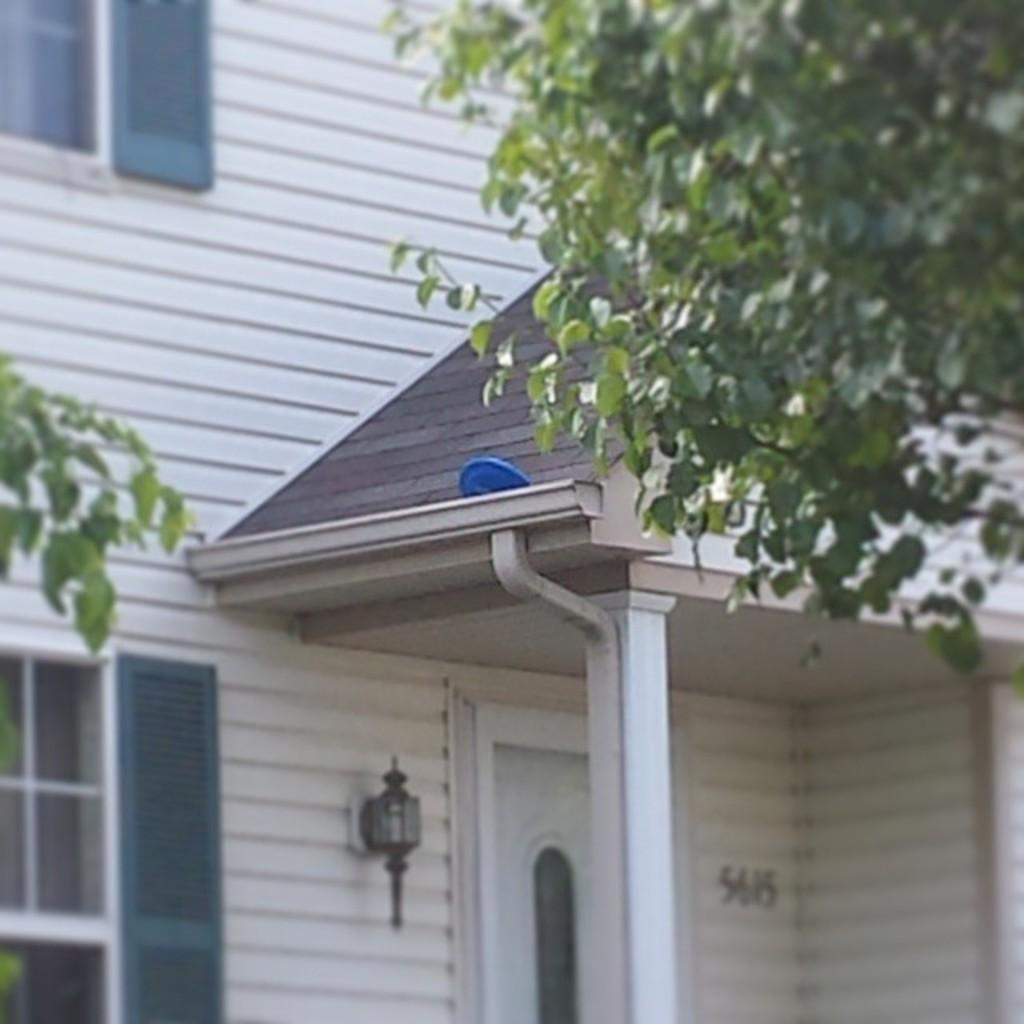What is the main subject of the picture? The main subject of the picture is a house. What can be seen in front of the house? There are trees in front of the house. How many sheep are grazing in the front yard of the house in the image? There are no sheep present in the image; it only features a house and trees in front of it. 